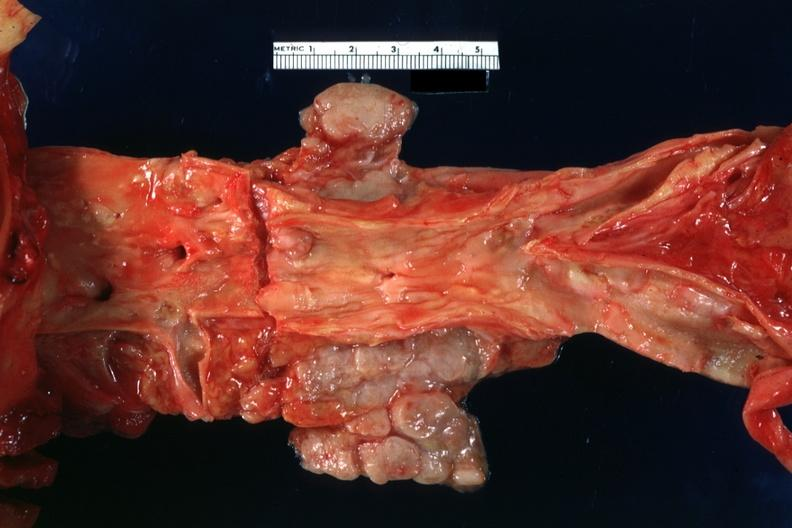does artery show periaortic nodes with metastatic carcinoma aorta shows good atherosclerotic plaques?
Answer the question using a single word or phrase. No 